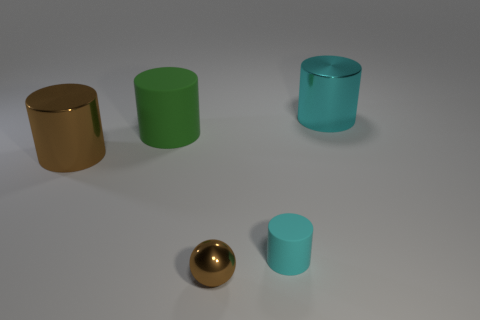Are there any objects that have the same color as the shiny ball?
Give a very brief answer. Yes. There is a brown thing on the right side of the brown metal thing that is on the left side of the small brown shiny thing in front of the large brown object; what shape is it?
Make the answer very short. Sphere. Is there a big green sphere that has the same material as the tiny brown thing?
Make the answer very short. No. There is a metal object that is on the right side of the cyan matte object; does it have the same color as the matte thing in front of the green thing?
Provide a succinct answer. Yes. Is the number of small cyan rubber cylinders in front of the small metal object less than the number of yellow shiny spheres?
Offer a very short reply. No. What number of objects are large green cylinders or large cylinders on the right side of the tiny brown metallic ball?
Provide a short and direct response. 2. There is a big cylinder that is made of the same material as the small cylinder; what is its color?
Your answer should be compact. Green. How many objects are either cyan cylinders or tiny brown rubber objects?
Offer a very short reply. 2. There is a matte cylinder that is the same size as the cyan shiny object; what color is it?
Offer a very short reply. Green. What number of objects are either big things behind the big brown cylinder or shiny cylinders?
Keep it short and to the point. 3. 